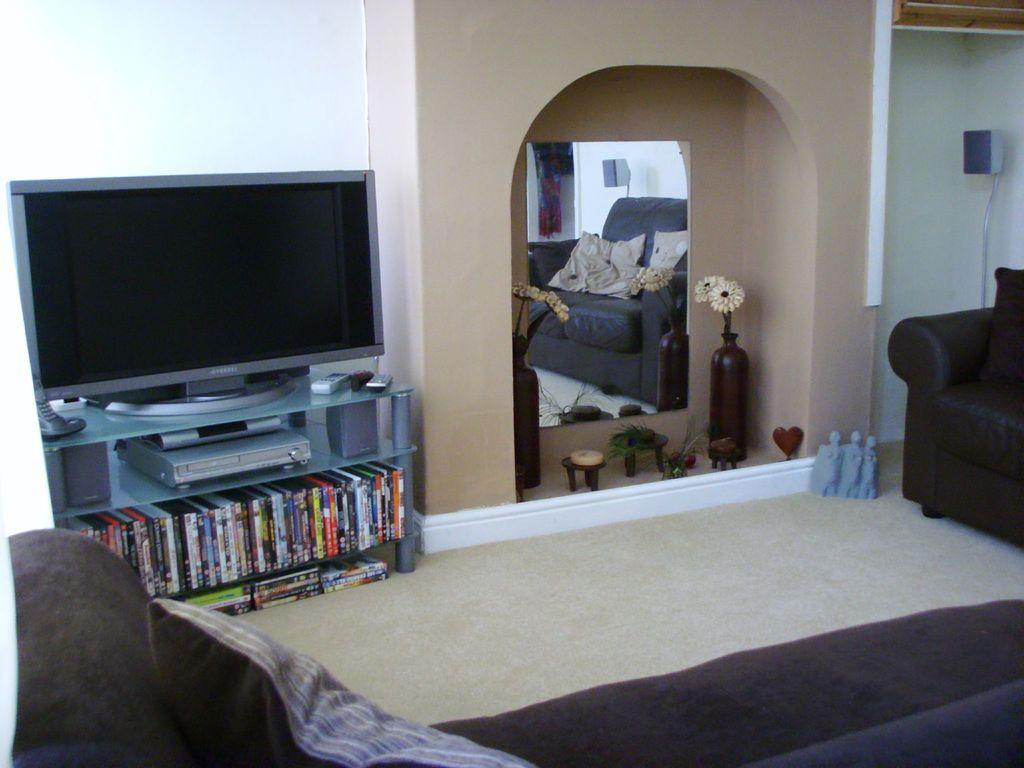What type of electronic device is present in the image? There is a television in the image. What items can be seen related to reading or learning? There are books in the image. What object might be used for personal grooming or checking appearance? There is a mirror in the image. What type of furniture is present in the image? There is a sofa in the image. What decorative item can be seen in the image? There is a flower vase in the image. What part of the room is visible in the image? The floor is visible in the image. What type of butter is being spread on the bread in the image? There is no bread or butter present in the image. Is there a band playing music in the image? There is no band or music playing in the image. 